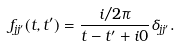<formula> <loc_0><loc_0><loc_500><loc_500>f _ { j j ^ { \prime } } ( t , t ^ { \prime } ) = \frac { i / 2 \pi } { t - t ^ { \prime } + i 0 } \delta _ { j j ^ { \prime } } .</formula> 